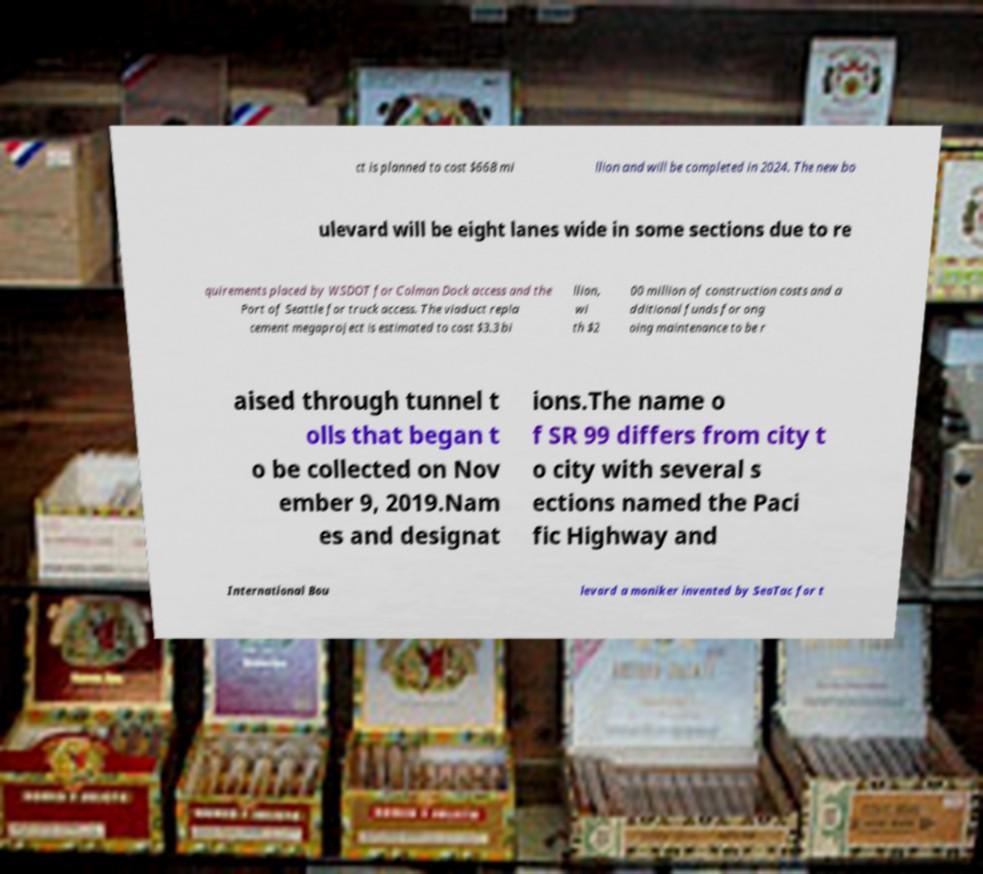Please identify and transcribe the text found in this image. ct is planned to cost $668 mi llion and will be completed in 2024. The new bo ulevard will be eight lanes wide in some sections due to re quirements placed by WSDOT for Colman Dock access and the Port of Seattle for truck access. The viaduct repla cement megaproject is estimated to cost $3.3 bi llion, wi th $2 00 million of construction costs and a dditional funds for ong oing maintenance to be r aised through tunnel t olls that began t o be collected on Nov ember 9, 2019.Nam es and designat ions.The name o f SR 99 differs from city t o city with several s ections named the Paci fic Highway and International Bou levard a moniker invented by SeaTac for t 